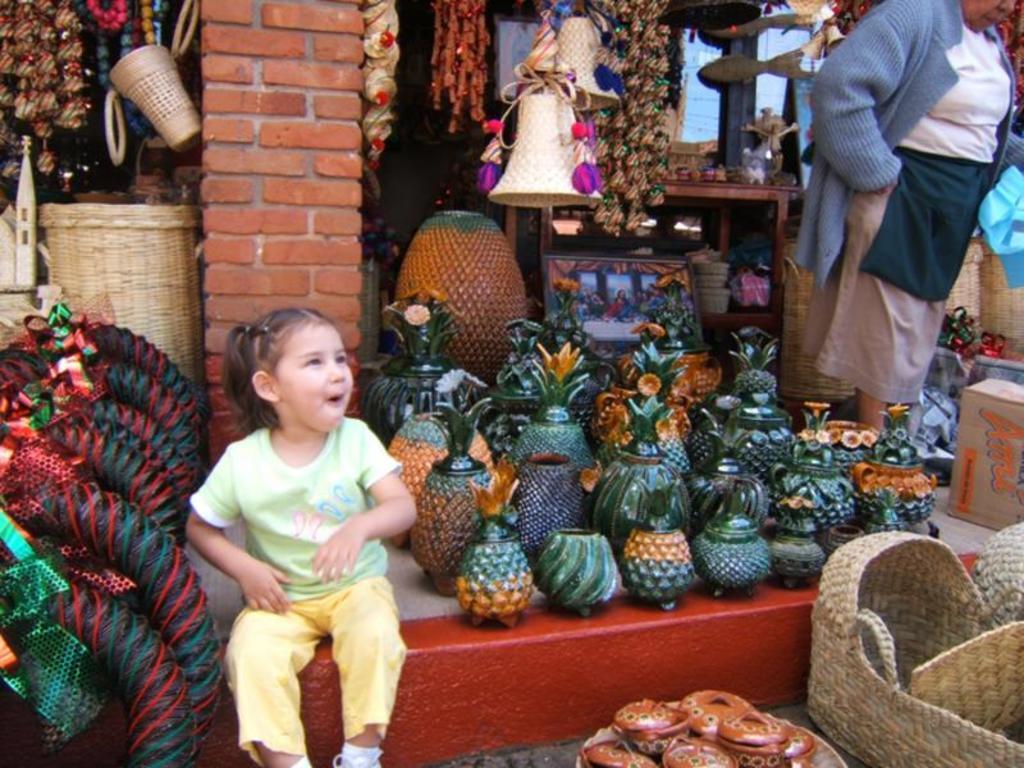Can you describe this image briefly? In this image we can see a girl sitting on a floor. Behind the girl we can see the stores. In the stores we can see a group of objects. On the right side, we can see a person. At the bottom we can see few objects. 